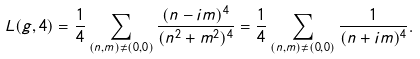<formula> <loc_0><loc_0><loc_500><loc_500>L ( g , 4 ) = \frac { 1 } { 4 } \sum _ { ( n , m ) \ne ( 0 , 0 ) } \frac { ( n - i m ) ^ { 4 } } { ( n ^ { 2 } + m ^ { 2 } ) ^ { 4 } } = \frac { 1 } { 4 } \sum _ { ( n , m ) \ne ( 0 , 0 ) } \frac { 1 } { ( n + i m ) ^ { 4 } } .</formula> 